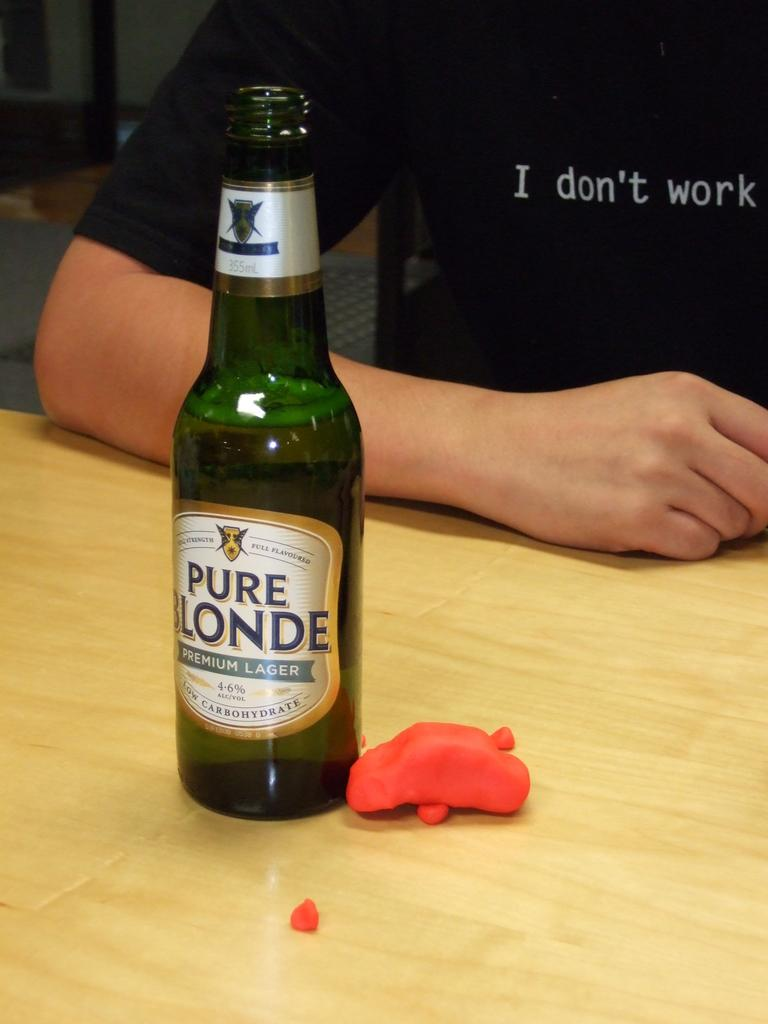<image>
Summarize the visual content of the image. A green bottle of Pure Blonde premium lager on a table. 